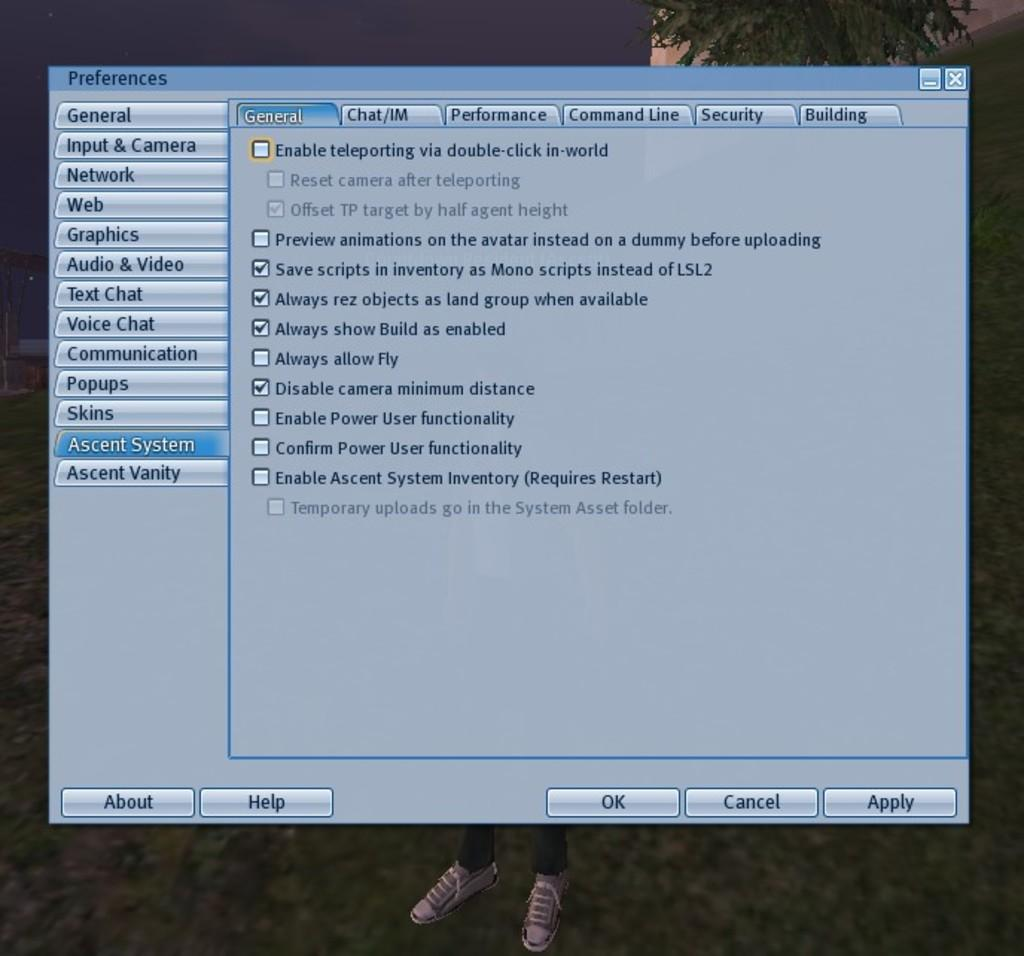What is the main object in the image? There is a chart box with text in the image. Can you describe any other visible features? There are legs visible at the bottom of the image. What is located at the top of the image? There is a tree at the top of the image. How many attempts did the lawyer make to climb the tree in the image? There is no lawyer or attempt to climb a tree present in the image. 